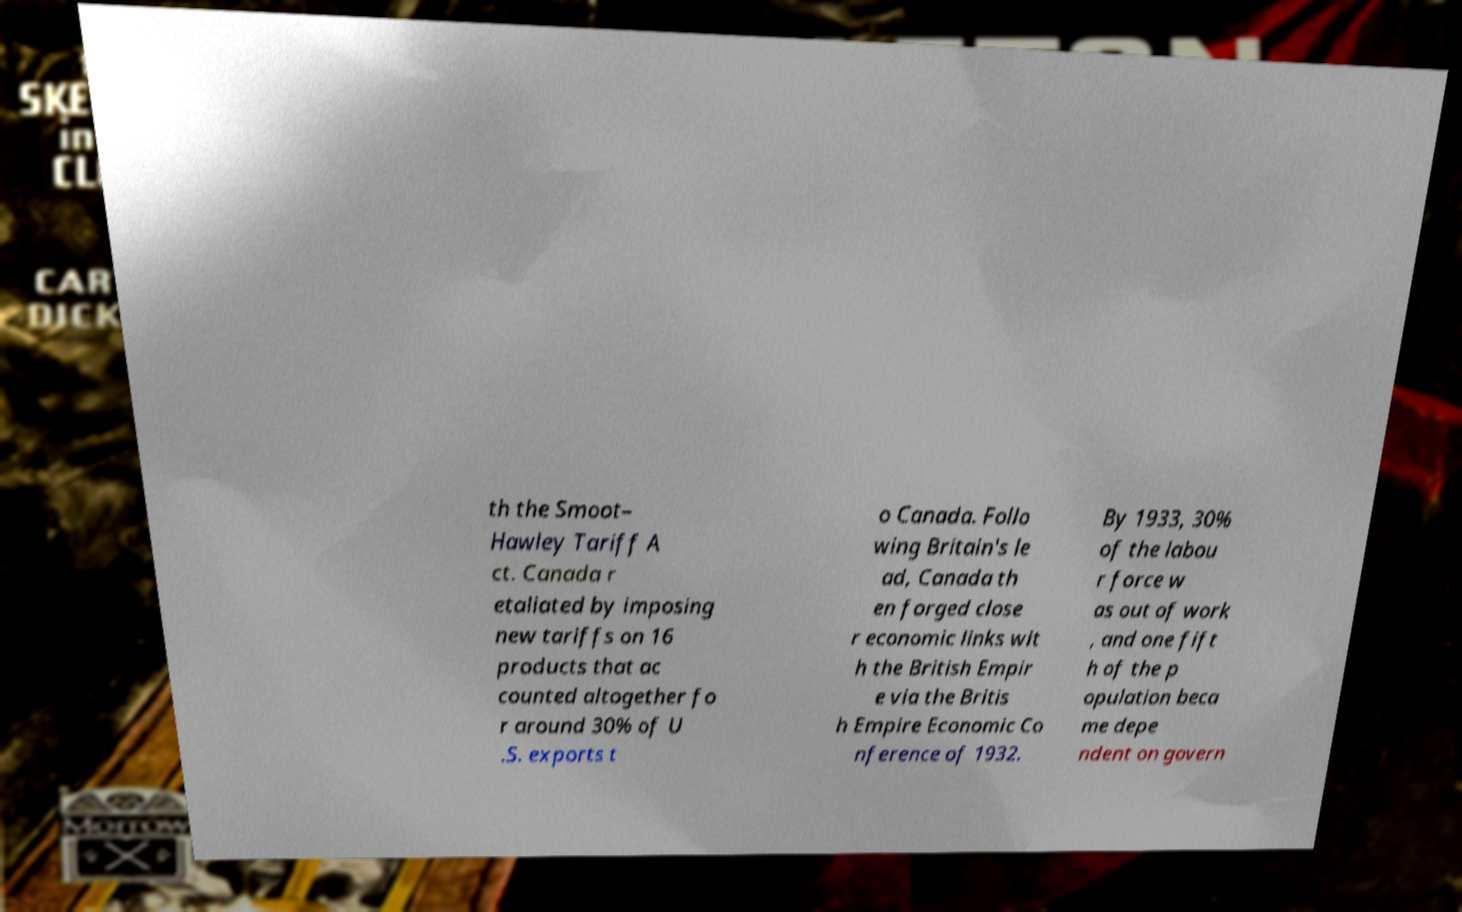Please identify and transcribe the text found in this image. th the Smoot– Hawley Tariff A ct. Canada r etaliated by imposing new tariffs on 16 products that ac counted altogether fo r around 30% of U .S. exports t o Canada. Follo wing Britain's le ad, Canada th en forged close r economic links wit h the British Empir e via the Britis h Empire Economic Co nference of 1932. By 1933, 30% of the labou r force w as out of work , and one fift h of the p opulation beca me depe ndent on govern 